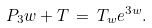Convert formula to latex. <formula><loc_0><loc_0><loc_500><loc_500>P _ { 3 } w + T \, = \, T _ { w } e ^ { 3 w } .</formula> 